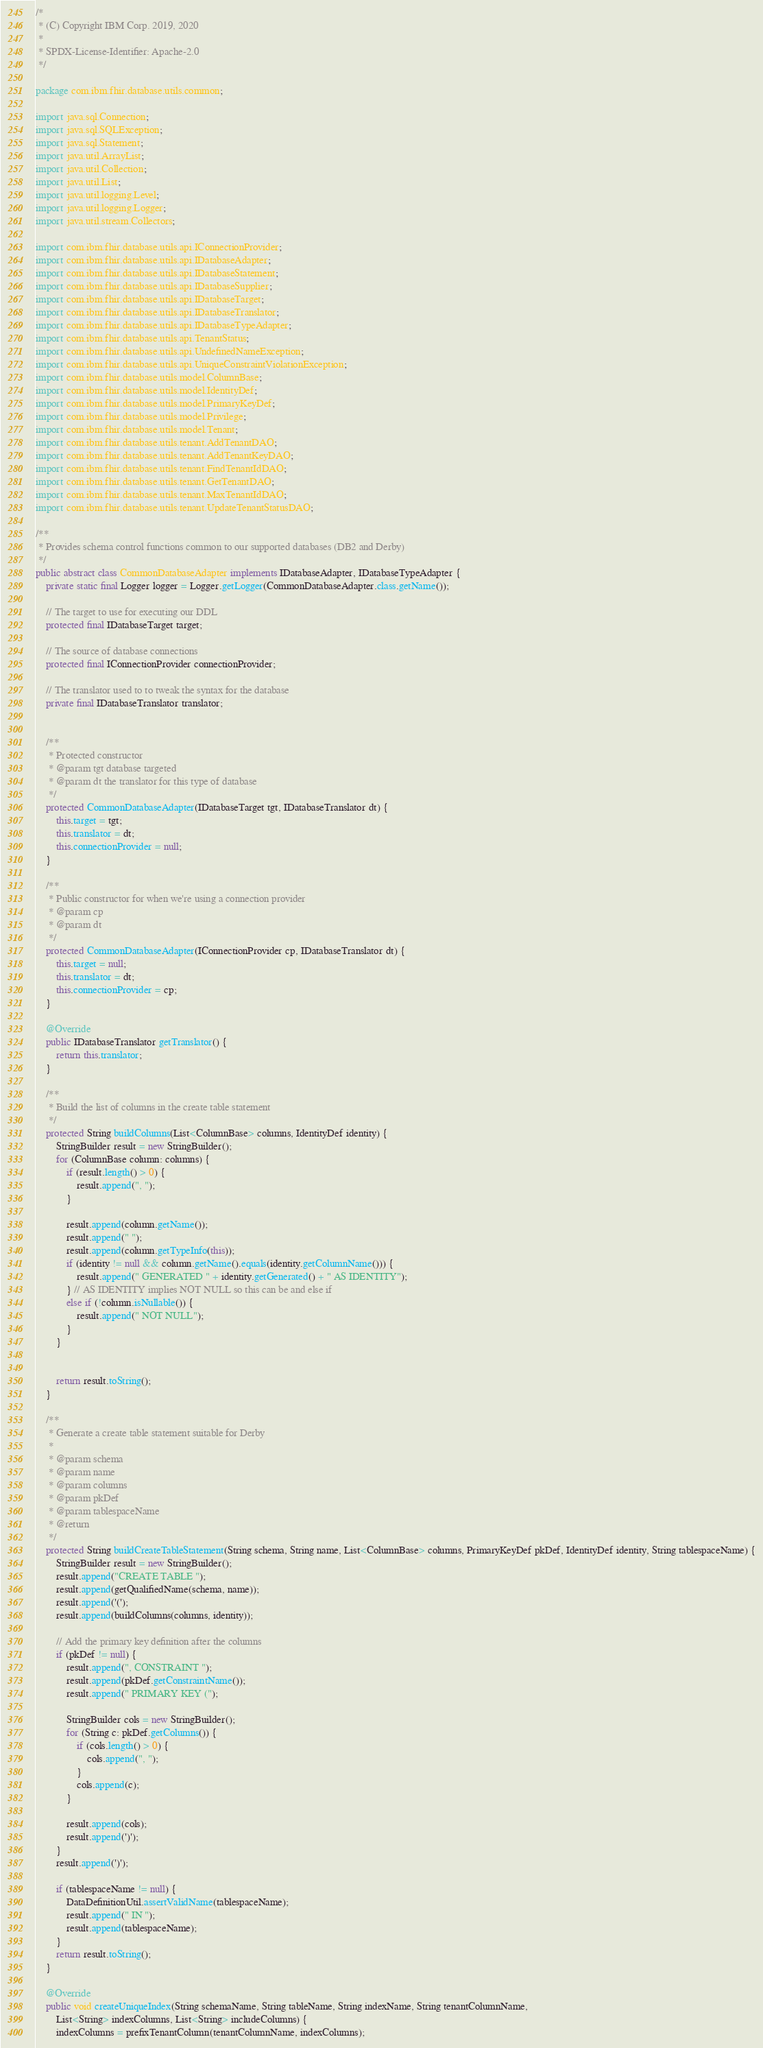Convert code to text. <code><loc_0><loc_0><loc_500><loc_500><_Java_>/*
 * (C) Copyright IBM Corp. 2019, 2020
 *
 * SPDX-License-Identifier: Apache-2.0
 */

package com.ibm.fhir.database.utils.common;

import java.sql.Connection;
import java.sql.SQLException;
import java.sql.Statement;
import java.util.ArrayList;
import java.util.Collection;
import java.util.List;
import java.util.logging.Level;
import java.util.logging.Logger;
import java.util.stream.Collectors;

import com.ibm.fhir.database.utils.api.IConnectionProvider;
import com.ibm.fhir.database.utils.api.IDatabaseAdapter;
import com.ibm.fhir.database.utils.api.IDatabaseStatement;
import com.ibm.fhir.database.utils.api.IDatabaseSupplier;
import com.ibm.fhir.database.utils.api.IDatabaseTarget;
import com.ibm.fhir.database.utils.api.IDatabaseTranslator;
import com.ibm.fhir.database.utils.api.IDatabaseTypeAdapter;
import com.ibm.fhir.database.utils.api.TenantStatus;
import com.ibm.fhir.database.utils.api.UndefinedNameException;
import com.ibm.fhir.database.utils.api.UniqueConstraintViolationException;
import com.ibm.fhir.database.utils.model.ColumnBase;
import com.ibm.fhir.database.utils.model.IdentityDef;
import com.ibm.fhir.database.utils.model.PrimaryKeyDef;
import com.ibm.fhir.database.utils.model.Privilege;
import com.ibm.fhir.database.utils.model.Tenant;
import com.ibm.fhir.database.utils.tenant.AddTenantDAO;
import com.ibm.fhir.database.utils.tenant.AddTenantKeyDAO;
import com.ibm.fhir.database.utils.tenant.FindTenantIdDAO;
import com.ibm.fhir.database.utils.tenant.GetTenantDAO;
import com.ibm.fhir.database.utils.tenant.MaxTenantIdDAO;
import com.ibm.fhir.database.utils.tenant.UpdateTenantStatusDAO;

/**
 * Provides schema control functions common to our supported databases (DB2 and Derby)
 */
public abstract class CommonDatabaseAdapter implements IDatabaseAdapter, IDatabaseTypeAdapter {
    private static final Logger logger = Logger.getLogger(CommonDatabaseAdapter.class.getName());

    // The target to use for executing our DDL
    protected final IDatabaseTarget target;

    // The source of database connections
    protected final IConnectionProvider connectionProvider;

    // The translator used to to tweak the syntax for the database
    private final IDatabaseTranslator translator;


    /**
     * Protected constructor
     * @param tgt database targeted
     * @param dt the translator for this type of database
     */
    protected CommonDatabaseAdapter(IDatabaseTarget tgt, IDatabaseTranslator dt) {
        this.target = tgt;
        this.translator = dt;
        this.connectionProvider = null;
    }

    /**
     * Public constructor for when we're using a connection provider
     * @param cp
     * @param dt
     */
    protected CommonDatabaseAdapter(IConnectionProvider cp, IDatabaseTranslator dt) {
        this.target = null;
        this.translator = dt;
        this.connectionProvider = cp;
    }

    @Override
    public IDatabaseTranslator getTranslator() {
        return this.translator;
    }

    /**
     * Build the list of columns in the create table statement
     */
    protected String buildColumns(List<ColumnBase> columns, IdentityDef identity) {
        StringBuilder result = new StringBuilder();
        for (ColumnBase column: columns) {
            if (result.length() > 0) {
                result.append(", ");
            }

            result.append(column.getName());
            result.append(" ");
            result.append(column.getTypeInfo(this));
            if (identity != null && column.getName().equals(identity.getColumnName())) {
                result.append(" GENERATED " + identity.getGenerated() + " AS IDENTITY");
            } // AS IDENTITY implies NOT NULL so this can be and else if
            else if (!column.isNullable()) {
                result.append(" NOT NULL");
            }
        }


        return result.toString();
    }

    /**
     * Generate a create table statement suitable for Derby
     *
     * @param schema
     * @param name
     * @param columns
     * @param pkDef
     * @param tablespaceName
     * @return
     */
    protected String buildCreateTableStatement(String schema, String name, List<ColumnBase> columns, PrimaryKeyDef pkDef, IdentityDef identity, String tablespaceName) {
        StringBuilder result = new StringBuilder();
        result.append("CREATE TABLE ");
        result.append(getQualifiedName(schema, name));
        result.append('(');
        result.append(buildColumns(columns, identity));

        // Add the primary key definition after the columns
        if (pkDef != null) {
            result.append(", CONSTRAINT ");
            result.append(pkDef.getConstraintName());
            result.append(" PRIMARY KEY (");

            StringBuilder cols = new StringBuilder();
            for (String c: pkDef.getColumns()) {
                if (cols.length() > 0) {
                    cols.append(", ");
                }
                cols.append(c);
            }

            result.append(cols);
            result.append(')');
        }
        result.append(')');

        if (tablespaceName != null) {
            DataDefinitionUtil.assertValidName(tablespaceName);
            result.append(" IN ");
            result.append(tablespaceName);
        }
        return result.toString();
    }

    @Override
    public void createUniqueIndex(String schemaName, String tableName, String indexName, String tenantColumnName,
        List<String> indexColumns, List<String> includeColumns) {
        indexColumns = prefixTenantColumn(tenantColumnName, indexColumns);</code> 